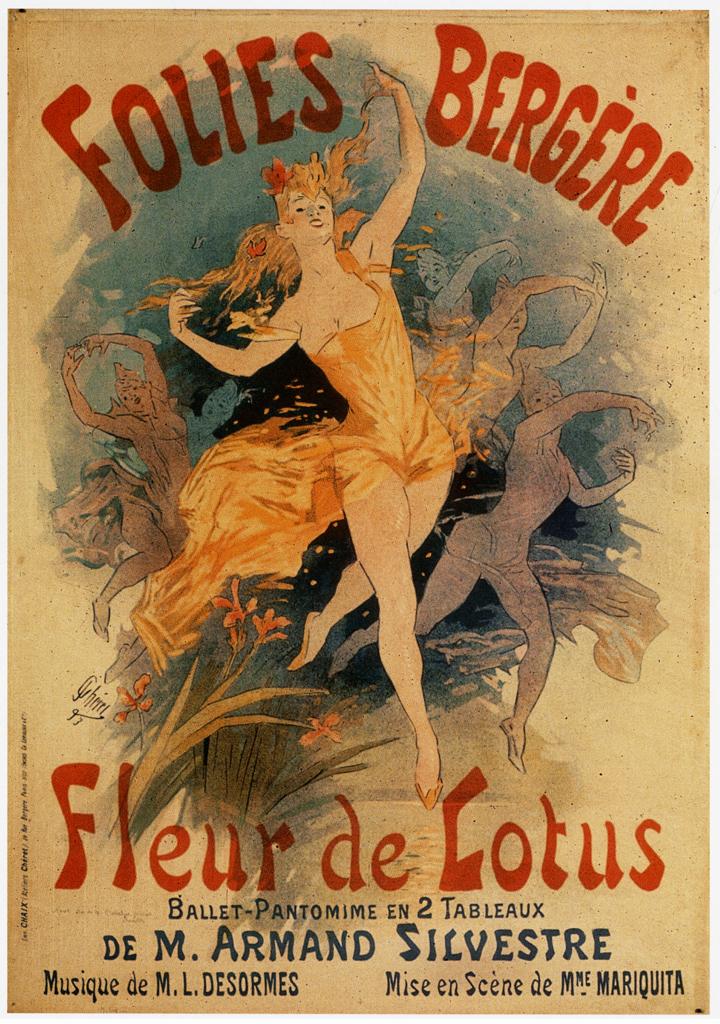Whom is the author of this?
Make the answer very short. De m. armand silvestre. What is the title of this work?
Provide a succinct answer. Fleur de lotus. 